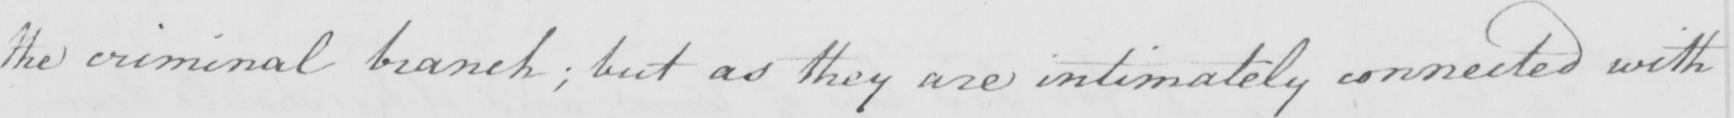Can you read and transcribe this handwriting? the criminal branch ; but as they are intimately connected with 